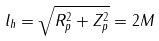Convert formula to latex. <formula><loc_0><loc_0><loc_500><loc_500>l _ { h } = \sqrt { R _ { p } ^ { 2 } + Z _ { p } ^ { 2 } } = 2 M</formula> 